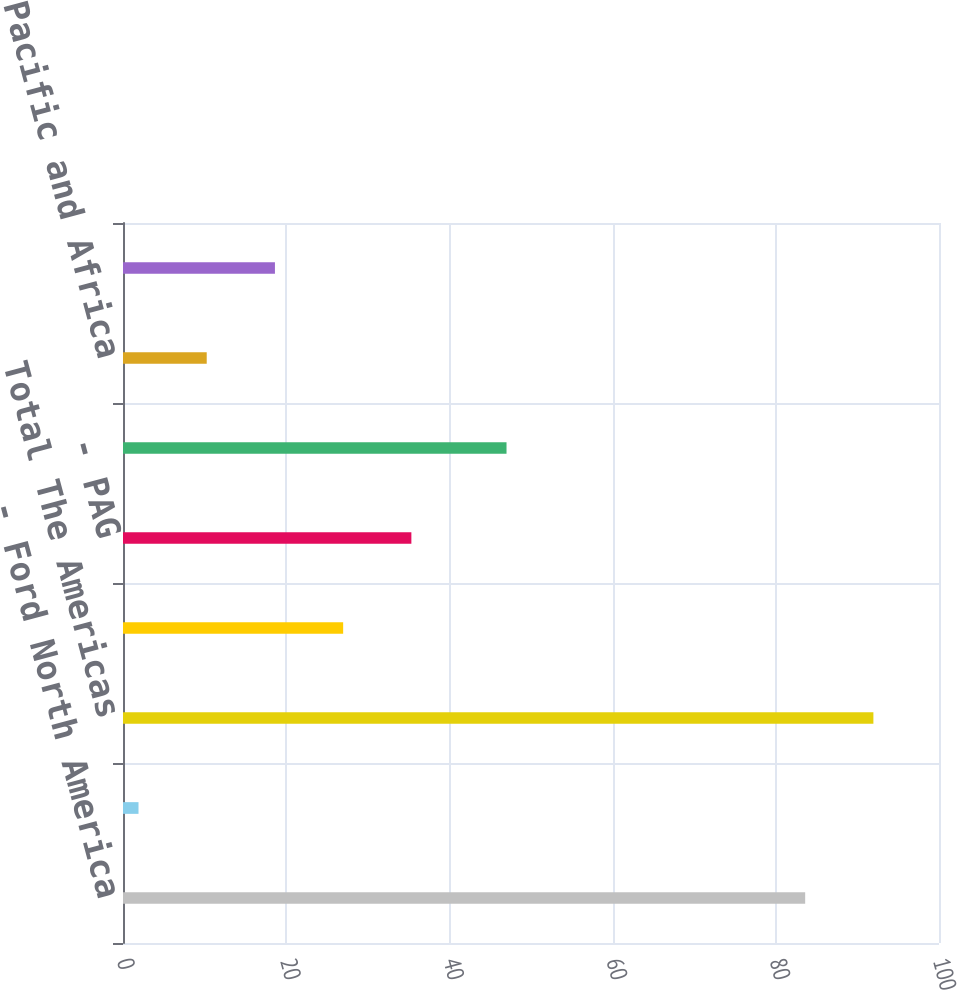Convert chart to OTSL. <chart><loc_0><loc_0><loc_500><loc_500><bar_chart><fcel>- Ford North America<fcel>- Ford South America<fcel>Total The Americas<fcel>- Ford Europe<fcel>- PAG<fcel>Total Ford Europe and PAG<fcel>- Ford Asia Pacific and Africa<fcel>Total Ford Asia Pacific and<nl><fcel>83.6<fcel>1.9<fcel>91.96<fcel>26.98<fcel>35.34<fcel>47<fcel>10.26<fcel>18.62<nl></chart> 